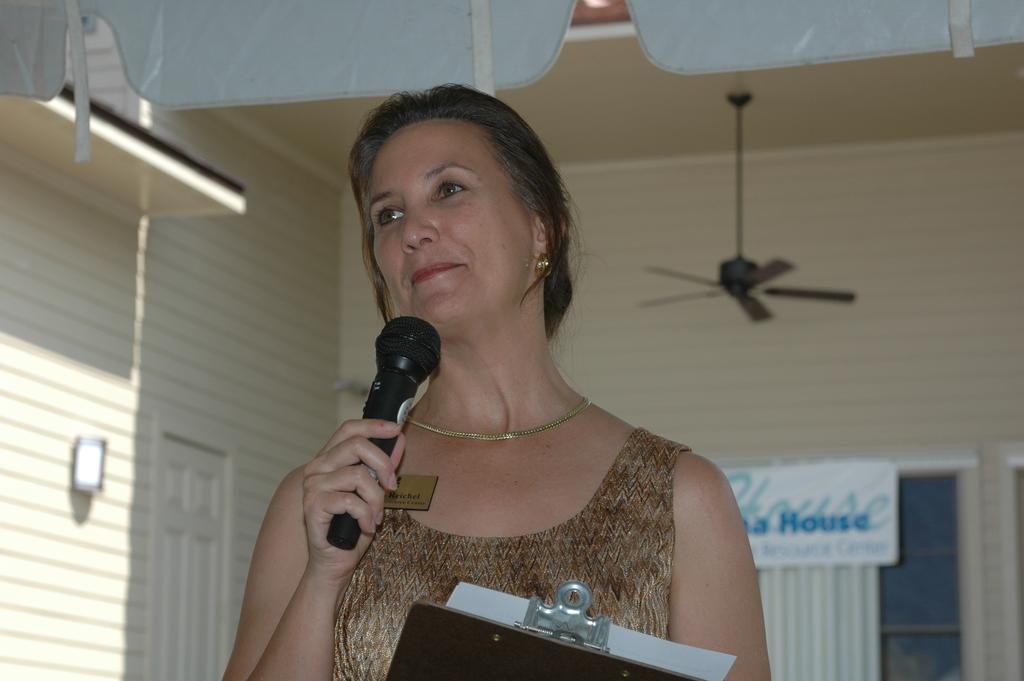Describe this image in one or two sentences. In this given picture there is a woman, holding a mic and smiling. There are some papers in her hand. In the background there is a fan and a wall here. 